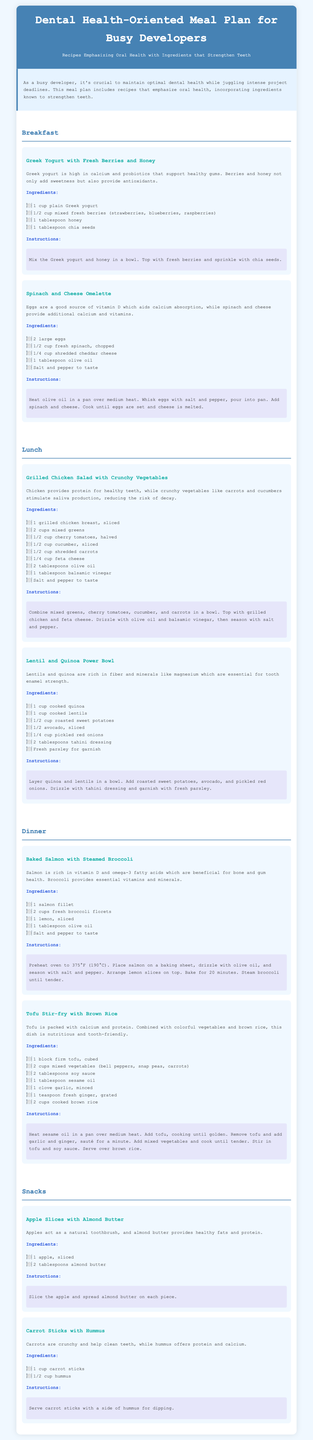What is the title of the document? The title is stated in the header of the document, specifically as “Dental Health-Oriented Meal Plan for Busy Developers.”
Answer: Dental Health-Oriented Meal Plan for Busy Developers Which meal includes Greek yogurt? The meal associated with Greek yogurt can be found in the breakfast section, noting its first recipe.
Answer: Breakfast How many ingredients does the Spinach and Cheese Omelette require? Counting the ingredients listed under the Spinach and Cheese Omelette recipe reveals the total number.
Answer: 5 What type of fish is mentioned in the dinner section? The document specifies the type of fish within the Baked Salmon with Steamed Broccoli recipe in the dinner section.
Answer: Salmon What is a key benefit of including apples in the meal plan? The document explains apples act as a natural toothbrush, emphasizing their oral health benefits.
Answer: Natural toothbrush Which ingredient aids calcium absorption? In the context of the Spinach and Cheese Omelette, eggs provide a significant nutrient that promotes calcium absorption.
Answer: Eggs How many recipes are included in the snack section? The snack section contains two distinct recipes listed for quick reference.
Answer: 2 What is the main protein source in the Tofu Stir-fry? The primary protein source is highlighted in the recipe details, specifically referring to tofu's nutritional profile.
Answer: Tofu What color is the background of the document? The background color is stated in the style section of the code, indicating its specific color value.
Answer: Light blue 